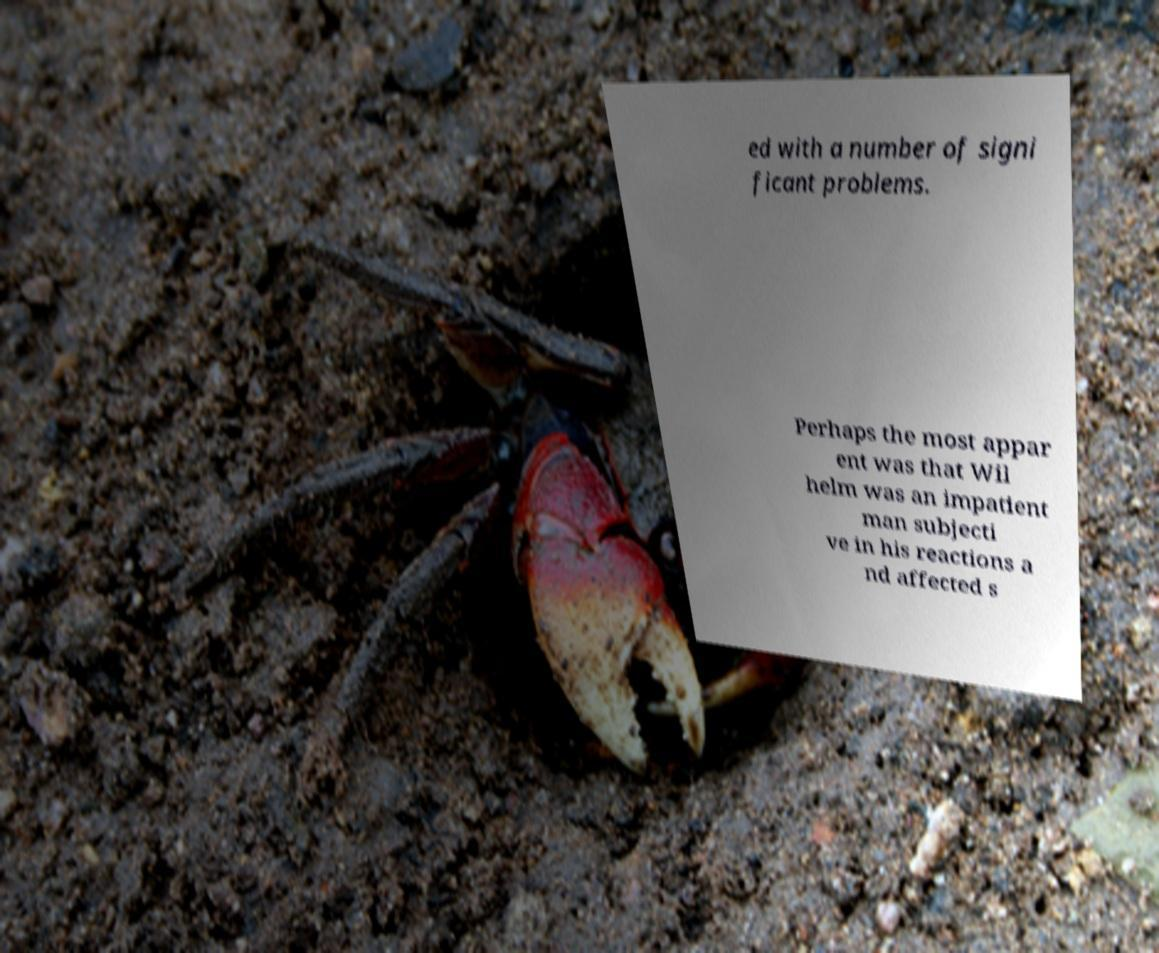Could you extract and type out the text from this image? ed with a number of signi ficant problems. Perhaps the most appar ent was that Wil helm was an impatient man subjecti ve in his reactions a nd affected s 